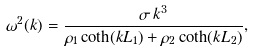<formula> <loc_0><loc_0><loc_500><loc_500>\omega ^ { 2 } ( k ) = \frac { \sigma \, k ^ { 3 } } { \rho _ { 1 } \coth ( k L _ { 1 } ) + \rho _ { 2 } \coth ( k L _ { 2 } ) } ,</formula> 